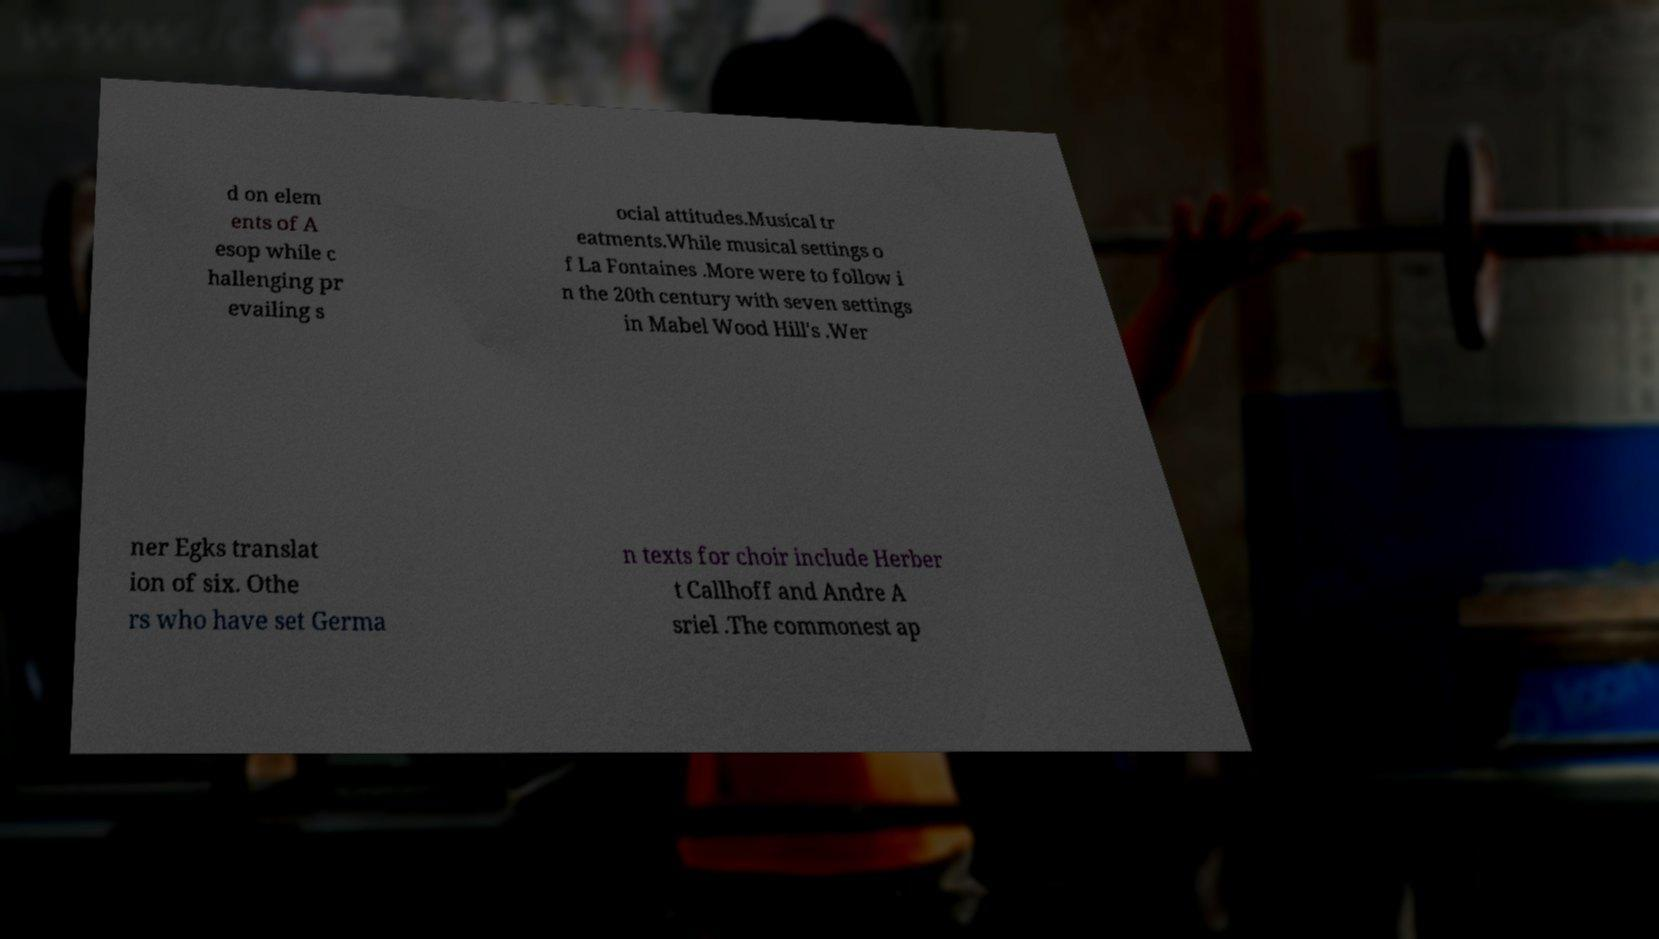Could you assist in decoding the text presented in this image and type it out clearly? d on elem ents of A esop while c hallenging pr evailing s ocial attitudes.Musical tr eatments.While musical settings o f La Fontaines .More were to follow i n the 20th century with seven settings in Mabel Wood Hill's .Wer ner Egks translat ion of six. Othe rs who have set Germa n texts for choir include Herber t Callhoff and Andre A sriel .The commonest ap 